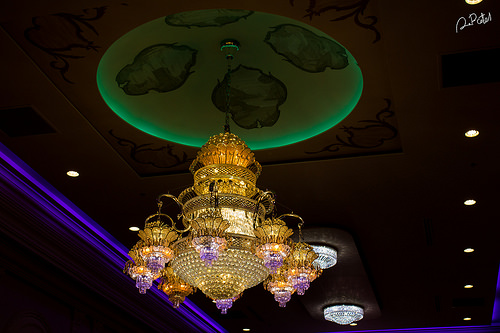<image>
Is the light under the chandelier? No. The light is not positioned under the chandelier. The vertical relationship between these objects is different. 